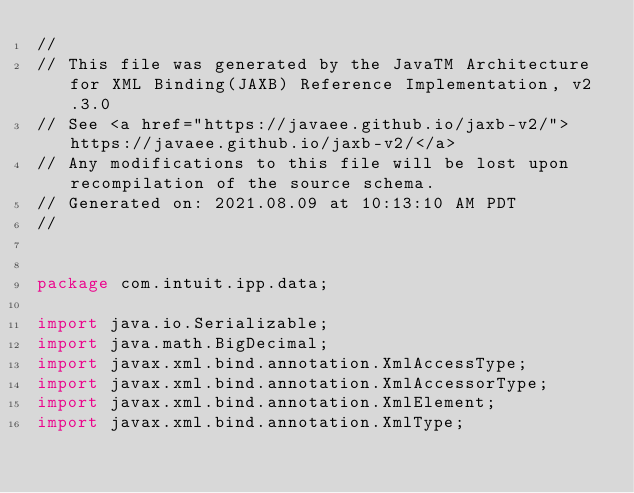<code> <loc_0><loc_0><loc_500><loc_500><_Java_>//
// This file was generated by the JavaTM Architecture for XML Binding(JAXB) Reference Implementation, v2.3.0 
// See <a href="https://javaee.github.io/jaxb-v2/">https://javaee.github.io/jaxb-v2/</a> 
// Any modifications to this file will be lost upon recompilation of the source schema. 
// Generated on: 2021.08.09 at 10:13:10 AM PDT 
//


package com.intuit.ipp.data;

import java.io.Serializable;
import java.math.BigDecimal;
import javax.xml.bind.annotation.XmlAccessType;
import javax.xml.bind.annotation.XmlAccessorType;
import javax.xml.bind.annotation.XmlElement;
import javax.xml.bind.annotation.XmlType;</code> 